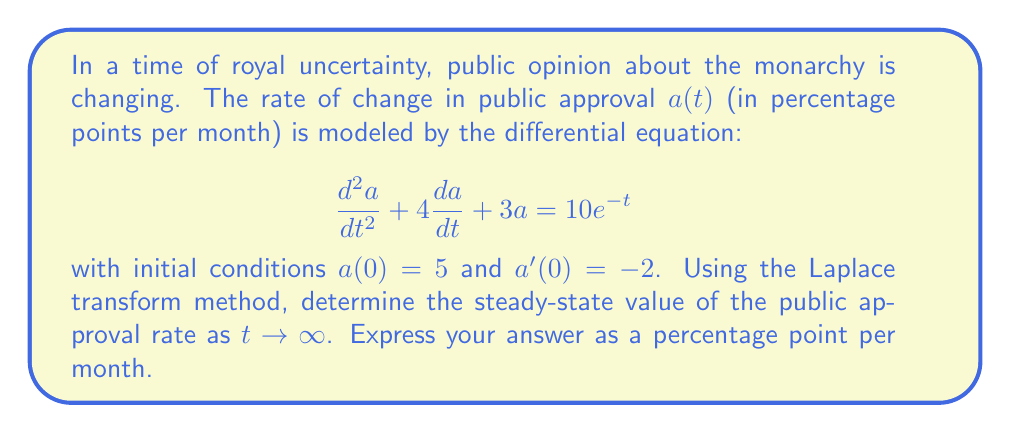Solve this math problem. Let's approach this step-by-step using the Laplace transform method:

1) First, let's take the Laplace transform of both sides of the equation:
   $$\mathcal{L}\{a''(t) + 4a'(t) + 3a(t)\} = \mathcal{L}\{10e^{-t}\}$$

2) Using Laplace transform properties:
   $$(s^2A(s) - sa(0) - a'(0)) + 4(sA(s) - a(0)) + 3A(s) = \frac{10}{s+1}$$
   where $A(s) = \mathcal{L}\{a(t)\}$

3) Substituting the initial conditions:
   $$(s^2A(s) - 5s + 2) + 4(sA(s) - 5) + 3A(s) = \frac{10}{s+1}$$

4) Simplifying:
   $$s^2A(s) + 4sA(s) + 3A(s) - 5s - 18 = \frac{10}{s+1}$$
   $$(s^2 + 4s + 3)A(s) = \frac{10}{s+1} + 5s + 18$$

5) Solving for $A(s)$:
   $$A(s) = \frac{10}{(s+1)(s^2 + 4s + 3)} + \frac{5s + 18}{s^2 + 4s + 3}$$

6) Using partial fraction decomposition (details omitted for brevity):
   $$A(s) = \frac{1}{s+1} + \frac{2}{s+1} + \frac{2}{s+3}$$

7) Taking the inverse Laplace transform:
   $$a(t) = e^{-t} + 2e^{-t} + 2e^{-3t} = 3e^{-t} + 2e^{-3t}$$

8) To find the steady-state value, we take the limit as $t \to \infty$:
   $$\lim_{t \to \infty} a(t) = \lim_{t \to \infty} (3e^{-t} + 2e^{-3t}) = 0$$

Therefore, the steady-state value of the public approval rate is 0 percentage points per month.
Answer: 0 percentage points per month 